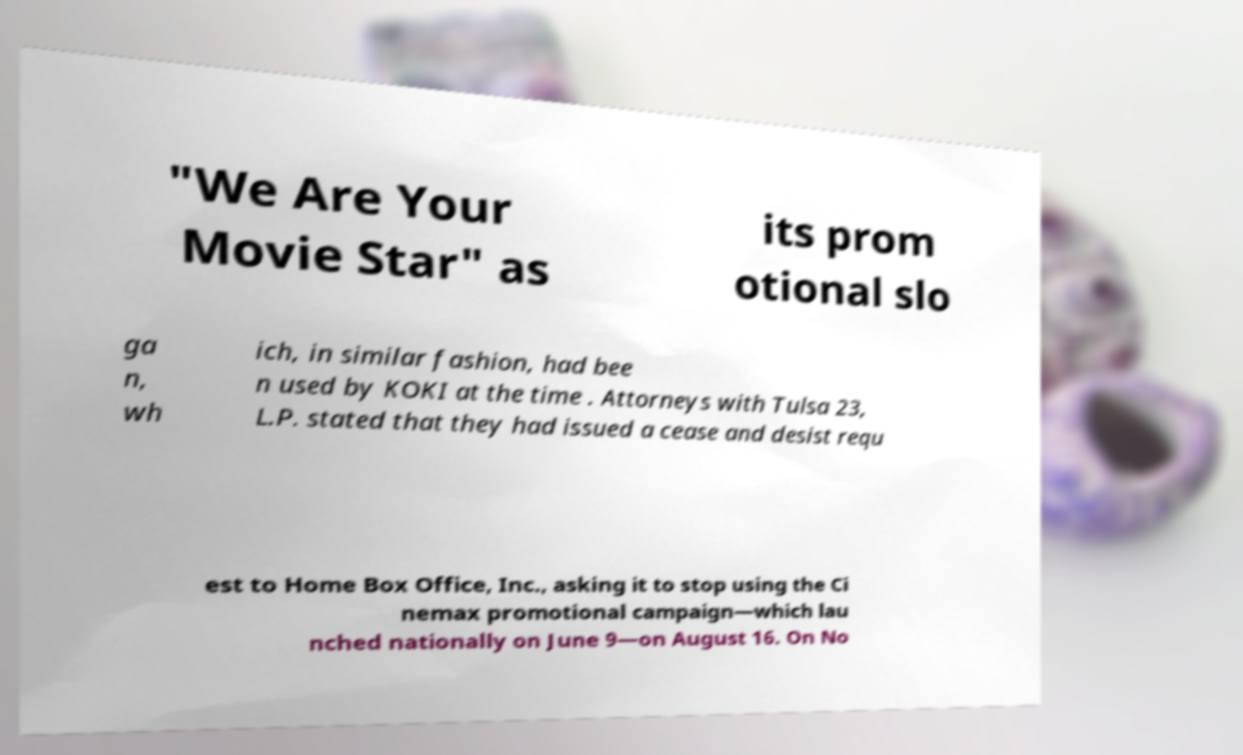Can you accurately transcribe the text from the provided image for me? "We Are Your Movie Star" as its prom otional slo ga n, wh ich, in similar fashion, had bee n used by KOKI at the time . Attorneys with Tulsa 23, L.P. stated that they had issued a cease and desist requ est to Home Box Office, Inc., asking it to stop using the Ci nemax promotional campaign—which lau nched nationally on June 9—on August 16. On No 